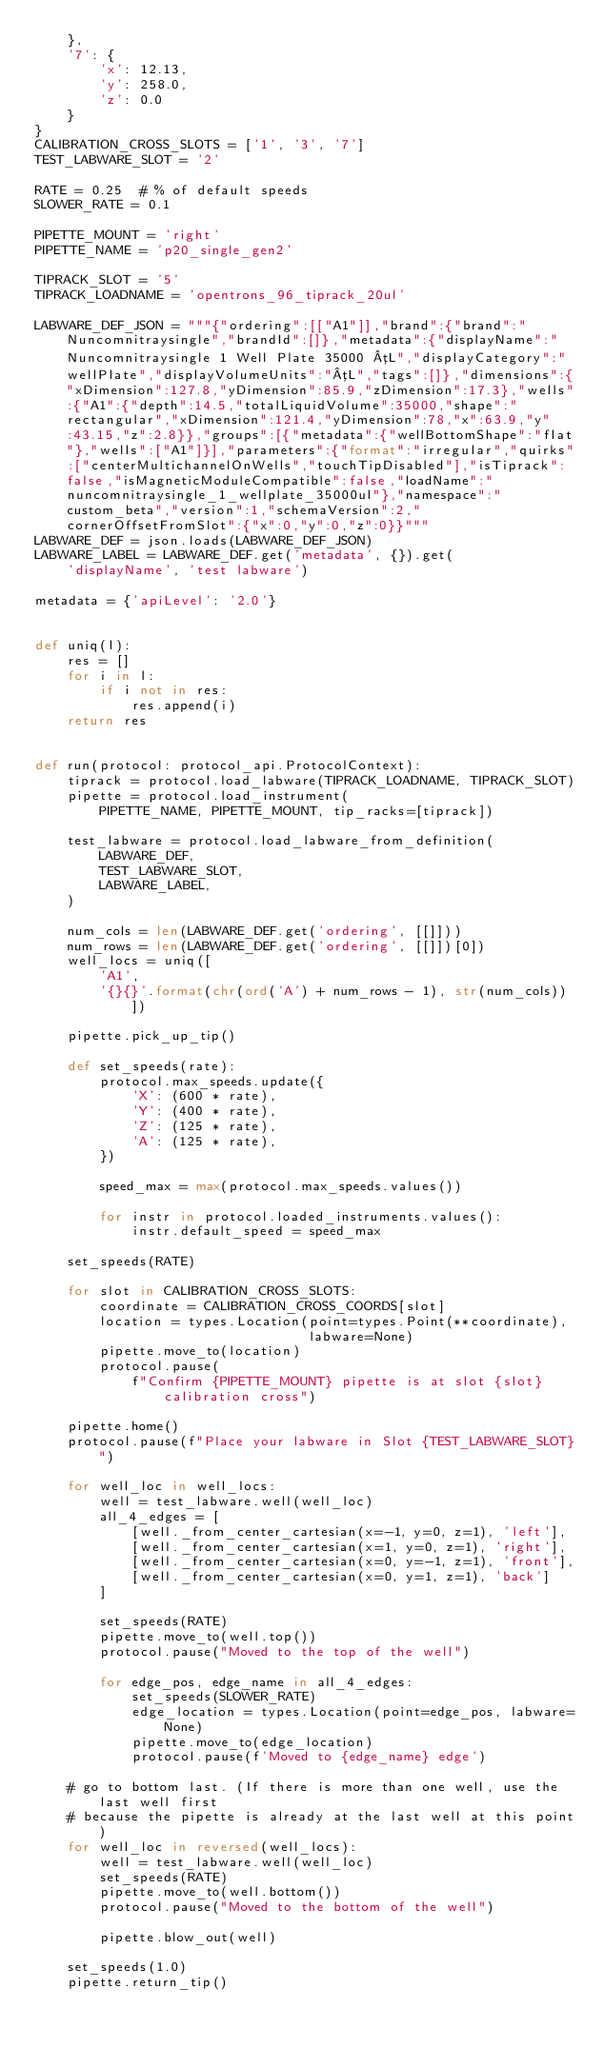<code> <loc_0><loc_0><loc_500><loc_500><_Python_>    },
    '7': {
        'x': 12.13,
        'y': 258.0,
        'z': 0.0
    }
}
CALIBRATION_CROSS_SLOTS = ['1', '3', '7']
TEST_LABWARE_SLOT = '2'

RATE = 0.25  # % of default speeds
SLOWER_RATE = 0.1

PIPETTE_MOUNT = 'right'
PIPETTE_NAME = 'p20_single_gen2'

TIPRACK_SLOT = '5'
TIPRACK_LOADNAME = 'opentrons_96_tiprack_20ul'

LABWARE_DEF_JSON = """{"ordering":[["A1"]],"brand":{"brand":"Nuncomnitraysingle","brandId":[]},"metadata":{"displayName":"Nuncomnitraysingle 1 Well Plate 35000 µL","displayCategory":"wellPlate","displayVolumeUnits":"µL","tags":[]},"dimensions":{"xDimension":127.8,"yDimension":85.9,"zDimension":17.3},"wells":{"A1":{"depth":14.5,"totalLiquidVolume":35000,"shape":"rectangular","xDimension":121.4,"yDimension":78,"x":63.9,"y":43.15,"z":2.8}},"groups":[{"metadata":{"wellBottomShape":"flat"},"wells":["A1"]}],"parameters":{"format":"irregular","quirks":["centerMultichannelOnWells","touchTipDisabled"],"isTiprack":false,"isMagneticModuleCompatible":false,"loadName":"nuncomnitraysingle_1_wellplate_35000ul"},"namespace":"custom_beta","version":1,"schemaVersion":2,"cornerOffsetFromSlot":{"x":0,"y":0,"z":0}}"""
LABWARE_DEF = json.loads(LABWARE_DEF_JSON)
LABWARE_LABEL = LABWARE_DEF.get('metadata', {}).get(
    'displayName', 'test labware')

metadata = {'apiLevel': '2.0'}


def uniq(l):
    res = []
    for i in l:
        if i not in res:
            res.append(i)
    return res


def run(protocol: protocol_api.ProtocolContext):
    tiprack = protocol.load_labware(TIPRACK_LOADNAME, TIPRACK_SLOT)
    pipette = protocol.load_instrument(
        PIPETTE_NAME, PIPETTE_MOUNT, tip_racks=[tiprack])

    test_labware = protocol.load_labware_from_definition(
        LABWARE_DEF,
        TEST_LABWARE_SLOT,
        LABWARE_LABEL,
    )

    num_cols = len(LABWARE_DEF.get('ordering', [[]]))
    num_rows = len(LABWARE_DEF.get('ordering', [[]])[0])
    well_locs = uniq([
        'A1',
        '{}{}'.format(chr(ord('A') + num_rows - 1), str(num_cols))])

    pipette.pick_up_tip()

    def set_speeds(rate):
        protocol.max_speeds.update({
            'X': (600 * rate),
            'Y': (400 * rate),
            'Z': (125 * rate),
            'A': (125 * rate),
        })

        speed_max = max(protocol.max_speeds.values())

        for instr in protocol.loaded_instruments.values():
            instr.default_speed = speed_max

    set_speeds(RATE)

    for slot in CALIBRATION_CROSS_SLOTS:
        coordinate = CALIBRATION_CROSS_COORDS[slot]
        location = types.Location(point=types.Point(**coordinate),
                                  labware=None)
        pipette.move_to(location)
        protocol.pause(
            f"Confirm {PIPETTE_MOUNT} pipette is at slot {slot} calibration cross")

    pipette.home()
    protocol.pause(f"Place your labware in Slot {TEST_LABWARE_SLOT}")

    for well_loc in well_locs:
        well = test_labware.well(well_loc)
        all_4_edges = [
            [well._from_center_cartesian(x=-1, y=0, z=1), 'left'],
            [well._from_center_cartesian(x=1, y=0, z=1), 'right'],
            [well._from_center_cartesian(x=0, y=-1, z=1), 'front'],
            [well._from_center_cartesian(x=0, y=1, z=1), 'back']
        ]

        set_speeds(RATE)
        pipette.move_to(well.top())
        protocol.pause("Moved to the top of the well")

        for edge_pos, edge_name in all_4_edges:
            set_speeds(SLOWER_RATE)
            edge_location = types.Location(point=edge_pos, labware=None)
            pipette.move_to(edge_location)
            protocol.pause(f'Moved to {edge_name} edge')

    # go to bottom last. (If there is more than one well, use the last well first
    # because the pipette is already at the last well at this point)
    for well_loc in reversed(well_locs):
        well = test_labware.well(well_loc)
        set_speeds(RATE)
        pipette.move_to(well.bottom())
        protocol.pause("Moved to the bottom of the well")

        pipette.blow_out(well)

    set_speeds(1.0)
    pipette.return_tip()
</code> 